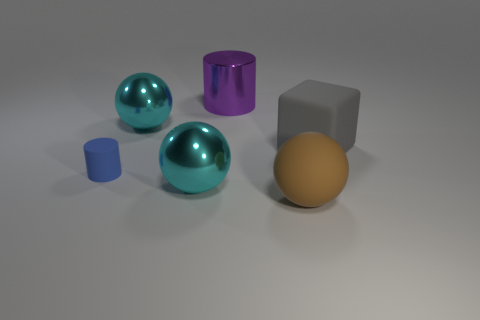There is a big brown object that is the same material as the tiny thing; what shape is it?
Your response must be concise. Sphere. How many other objects are the same shape as the purple object?
Give a very brief answer. 1. What is the material of the big purple cylinder?
Provide a succinct answer. Metal. How many cylinders are big shiny things or large gray things?
Ensure brevity in your answer.  1. What is the color of the sphere that is behind the small object?
Offer a terse response. Cyan. What number of cyan balls are the same size as the brown rubber ball?
Provide a succinct answer. 2. Does the rubber thing to the left of the brown object have the same shape as the big purple metal object that is right of the blue cylinder?
Your answer should be very brief. Yes. What is the big cyan object that is on the right side of the large cyan ball behind the matte thing that is left of the brown matte ball made of?
Provide a short and direct response. Metal. What shape is the brown object that is the same size as the purple shiny object?
Offer a terse response. Sphere. How big is the purple thing?
Your answer should be compact. Large. 